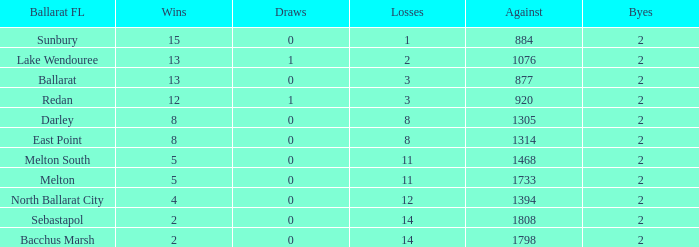For a ballarat fl team in melton south, how many losses have they experienced with an against value over 1468? 0.0. 